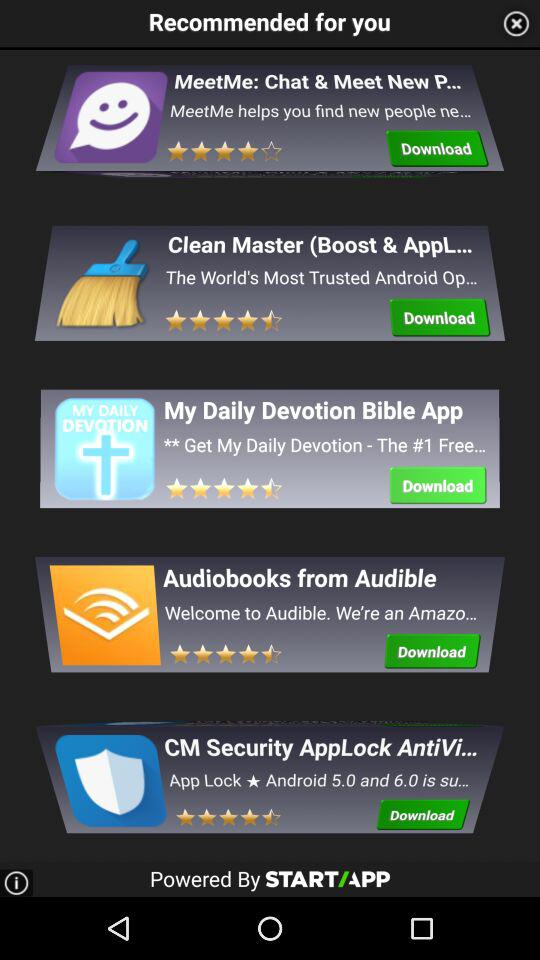What is the rating of "Audiobooks from Audible"? The rating of "Audiobooks from Audible" is 4.5 stars. 